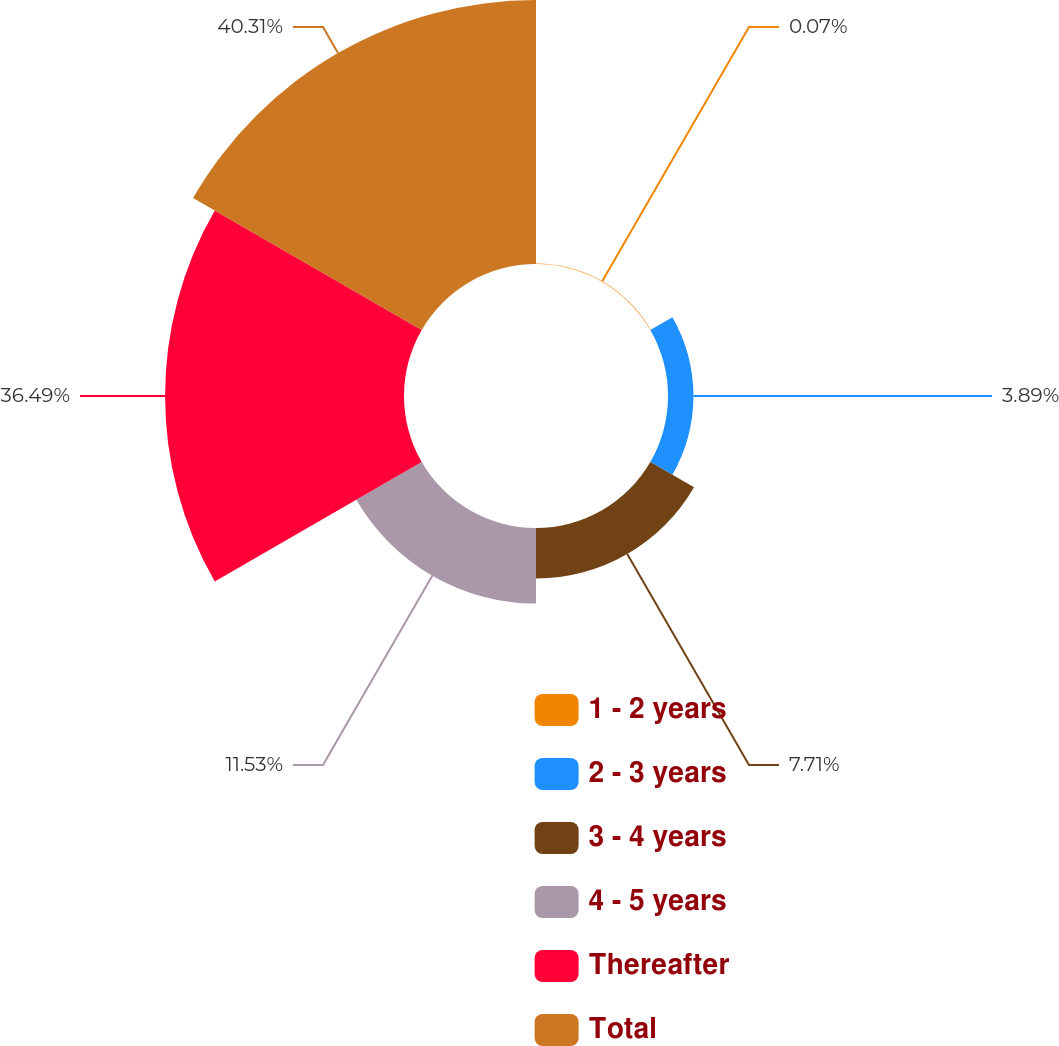<chart> <loc_0><loc_0><loc_500><loc_500><pie_chart><fcel>1 - 2 years<fcel>2 - 3 years<fcel>3 - 4 years<fcel>4 - 5 years<fcel>Thereafter<fcel>Total<nl><fcel>0.07%<fcel>3.89%<fcel>7.71%<fcel>11.53%<fcel>36.49%<fcel>40.32%<nl></chart> 